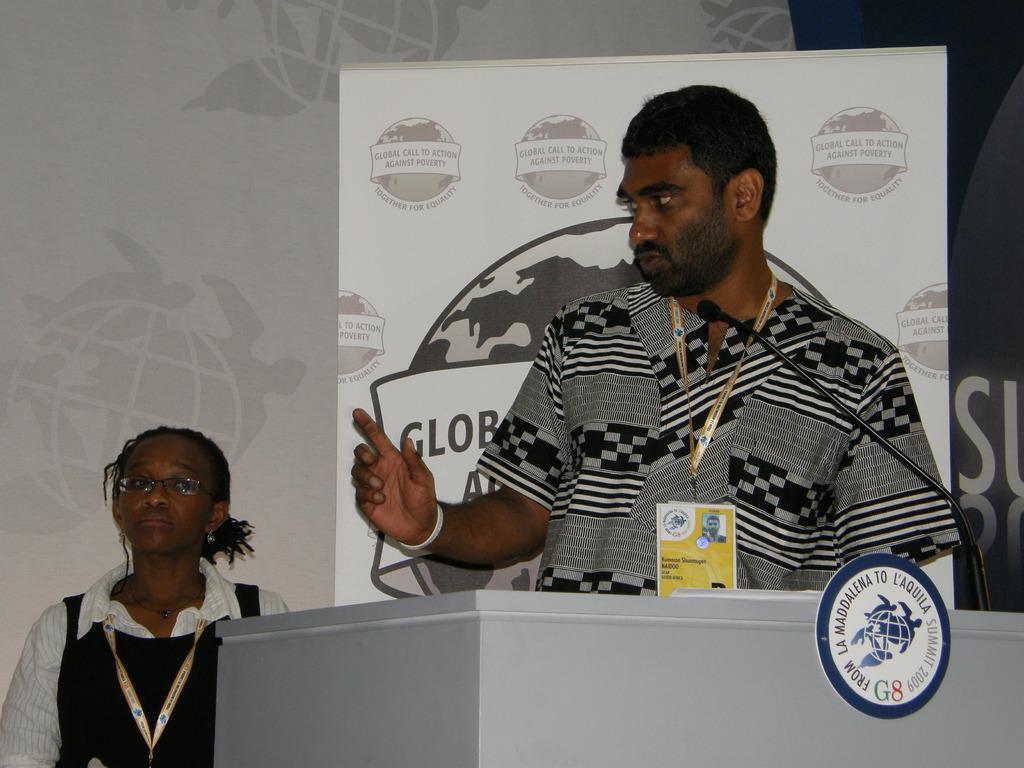Could you give a brief overview of what you see in this image? In this image I can see a woman, man, podium, board, mic and banners. A woman and man wore ID cards. In-front of the man there is a podium along with board and mic. 